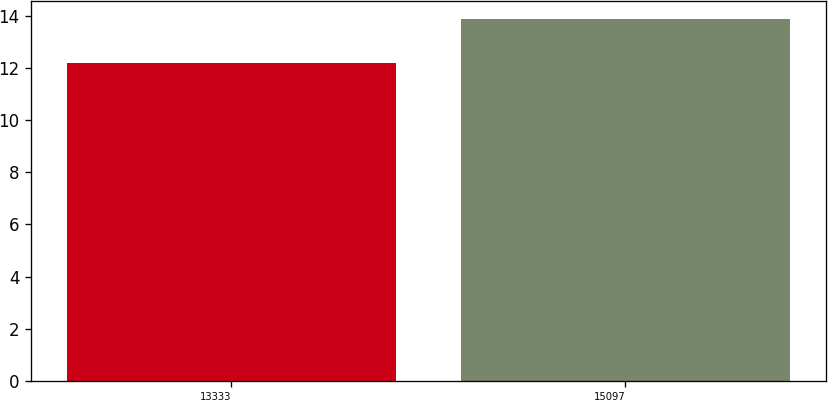<chart> <loc_0><loc_0><loc_500><loc_500><bar_chart><fcel>13333<fcel>15097<nl><fcel>12.2<fcel>13.9<nl></chart> 